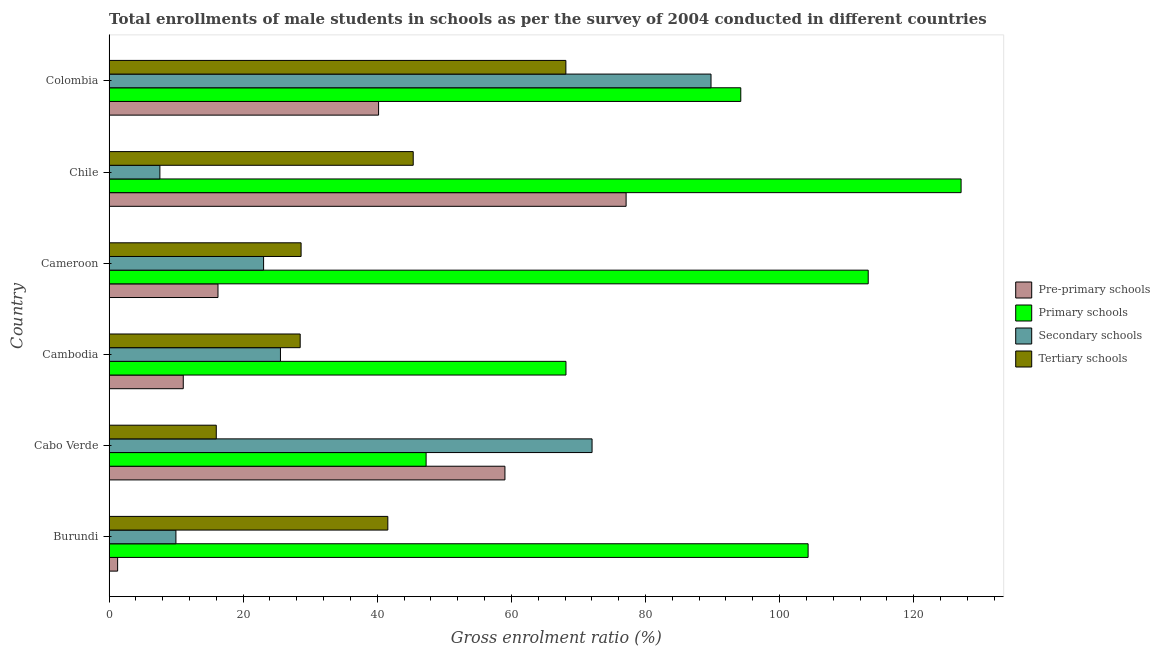What is the label of the 6th group of bars from the top?
Provide a succinct answer. Burundi. What is the gross enrolment ratio(male) in pre-primary schools in Chile?
Give a very brief answer. 77.11. Across all countries, what is the maximum gross enrolment ratio(male) in secondary schools?
Provide a succinct answer. 89.78. Across all countries, what is the minimum gross enrolment ratio(male) in primary schools?
Give a very brief answer. 47.28. In which country was the gross enrolment ratio(male) in tertiary schools maximum?
Give a very brief answer. Colombia. In which country was the gross enrolment ratio(male) in primary schools minimum?
Make the answer very short. Cabo Verde. What is the total gross enrolment ratio(male) in pre-primary schools in the graph?
Keep it short and to the point. 204.94. What is the difference between the gross enrolment ratio(male) in primary schools in Cambodia and that in Colombia?
Ensure brevity in your answer.  -26.07. What is the difference between the gross enrolment ratio(male) in pre-primary schools in Cameroon and the gross enrolment ratio(male) in secondary schools in Chile?
Provide a succinct answer. 8.66. What is the average gross enrolment ratio(male) in primary schools per country?
Your answer should be very brief. 92.37. What is the difference between the gross enrolment ratio(male) in pre-primary schools and gross enrolment ratio(male) in tertiary schools in Colombia?
Keep it short and to the point. -27.93. What is the ratio of the gross enrolment ratio(male) in secondary schools in Cameroon to that in Colombia?
Make the answer very short. 0.26. What is the difference between the highest and the second highest gross enrolment ratio(male) in pre-primary schools?
Offer a very short reply. 18.07. What is the difference between the highest and the lowest gross enrolment ratio(male) in secondary schools?
Your answer should be compact. 82.2. Is it the case that in every country, the sum of the gross enrolment ratio(male) in pre-primary schools and gross enrolment ratio(male) in primary schools is greater than the sum of gross enrolment ratio(male) in tertiary schools and gross enrolment ratio(male) in secondary schools?
Give a very brief answer. Yes. What does the 3rd bar from the top in Chile represents?
Your response must be concise. Primary schools. What does the 3rd bar from the bottom in Burundi represents?
Keep it short and to the point. Secondary schools. How many bars are there?
Your response must be concise. 24. What is the difference between two consecutive major ticks on the X-axis?
Your answer should be compact. 20. Does the graph contain any zero values?
Your response must be concise. No. Does the graph contain grids?
Offer a terse response. No. Where does the legend appear in the graph?
Your answer should be compact. Center right. How many legend labels are there?
Your answer should be very brief. 4. How are the legend labels stacked?
Make the answer very short. Vertical. What is the title of the graph?
Ensure brevity in your answer.  Total enrollments of male students in schools as per the survey of 2004 conducted in different countries. What is the label or title of the X-axis?
Your response must be concise. Gross enrolment ratio (%). What is the label or title of the Y-axis?
Your answer should be compact. Country. What is the Gross enrolment ratio (%) in Pre-primary schools in Burundi?
Offer a terse response. 1.28. What is the Gross enrolment ratio (%) in Primary schools in Burundi?
Provide a succinct answer. 104.26. What is the Gross enrolment ratio (%) in Secondary schools in Burundi?
Make the answer very short. 9.97. What is the Gross enrolment ratio (%) in Tertiary schools in Burundi?
Provide a succinct answer. 41.58. What is the Gross enrolment ratio (%) of Pre-primary schools in Cabo Verde?
Offer a terse response. 59.04. What is the Gross enrolment ratio (%) of Primary schools in Cabo Verde?
Your answer should be very brief. 47.28. What is the Gross enrolment ratio (%) of Secondary schools in Cabo Verde?
Ensure brevity in your answer.  72.04. What is the Gross enrolment ratio (%) of Tertiary schools in Cabo Verde?
Offer a very short reply. 15.99. What is the Gross enrolment ratio (%) in Pre-primary schools in Cambodia?
Your answer should be very brief. 11.07. What is the Gross enrolment ratio (%) of Primary schools in Cambodia?
Your response must be concise. 68.14. What is the Gross enrolment ratio (%) in Secondary schools in Cambodia?
Keep it short and to the point. 25.56. What is the Gross enrolment ratio (%) of Tertiary schools in Cambodia?
Offer a terse response. 28.51. What is the Gross enrolment ratio (%) of Pre-primary schools in Cameroon?
Your response must be concise. 16.24. What is the Gross enrolment ratio (%) in Primary schools in Cameroon?
Offer a very short reply. 113.22. What is the Gross enrolment ratio (%) in Secondary schools in Cameroon?
Make the answer very short. 23.05. What is the Gross enrolment ratio (%) in Tertiary schools in Cameroon?
Give a very brief answer. 28.64. What is the Gross enrolment ratio (%) in Pre-primary schools in Chile?
Offer a terse response. 77.11. What is the Gross enrolment ratio (%) of Primary schools in Chile?
Make the answer very short. 127.07. What is the Gross enrolment ratio (%) of Secondary schools in Chile?
Provide a succinct answer. 7.58. What is the Gross enrolment ratio (%) in Tertiary schools in Chile?
Give a very brief answer. 45.36. What is the Gross enrolment ratio (%) of Pre-primary schools in Colombia?
Your response must be concise. 40.2. What is the Gross enrolment ratio (%) of Primary schools in Colombia?
Your answer should be compact. 94.22. What is the Gross enrolment ratio (%) of Secondary schools in Colombia?
Provide a succinct answer. 89.78. What is the Gross enrolment ratio (%) of Tertiary schools in Colombia?
Your response must be concise. 68.13. Across all countries, what is the maximum Gross enrolment ratio (%) of Pre-primary schools?
Provide a succinct answer. 77.11. Across all countries, what is the maximum Gross enrolment ratio (%) of Primary schools?
Offer a very short reply. 127.07. Across all countries, what is the maximum Gross enrolment ratio (%) in Secondary schools?
Keep it short and to the point. 89.78. Across all countries, what is the maximum Gross enrolment ratio (%) of Tertiary schools?
Your answer should be very brief. 68.13. Across all countries, what is the minimum Gross enrolment ratio (%) of Pre-primary schools?
Your response must be concise. 1.28. Across all countries, what is the minimum Gross enrolment ratio (%) of Primary schools?
Provide a short and direct response. 47.28. Across all countries, what is the minimum Gross enrolment ratio (%) of Secondary schools?
Give a very brief answer. 7.58. Across all countries, what is the minimum Gross enrolment ratio (%) in Tertiary schools?
Give a very brief answer. 15.99. What is the total Gross enrolment ratio (%) of Pre-primary schools in the graph?
Your response must be concise. 204.94. What is the total Gross enrolment ratio (%) in Primary schools in the graph?
Ensure brevity in your answer.  554.2. What is the total Gross enrolment ratio (%) of Secondary schools in the graph?
Your response must be concise. 227.97. What is the total Gross enrolment ratio (%) of Tertiary schools in the graph?
Make the answer very short. 228.2. What is the difference between the Gross enrolment ratio (%) in Pre-primary schools in Burundi and that in Cabo Verde?
Offer a terse response. -57.76. What is the difference between the Gross enrolment ratio (%) of Primary schools in Burundi and that in Cabo Verde?
Your response must be concise. 56.97. What is the difference between the Gross enrolment ratio (%) in Secondary schools in Burundi and that in Cabo Verde?
Ensure brevity in your answer.  -62.07. What is the difference between the Gross enrolment ratio (%) in Tertiary schools in Burundi and that in Cabo Verde?
Provide a succinct answer. 25.59. What is the difference between the Gross enrolment ratio (%) in Pre-primary schools in Burundi and that in Cambodia?
Provide a short and direct response. -9.79. What is the difference between the Gross enrolment ratio (%) in Primary schools in Burundi and that in Cambodia?
Your answer should be compact. 36.11. What is the difference between the Gross enrolment ratio (%) in Secondary schools in Burundi and that in Cambodia?
Keep it short and to the point. -15.59. What is the difference between the Gross enrolment ratio (%) in Tertiary schools in Burundi and that in Cambodia?
Your answer should be compact. 13.07. What is the difference between the Gross enrolment ratio (%) of Pre-primary schools in Burundi and that in Cameroon?
Your response must be concise. -14.97. What is the difference between the Gross enrolment ratio (%) of Primary schools in Burundi and that in Cameroon?
Provide a short and direct response. -8.97. What is the difference between the Gross enrolment ratio (%) of Secondary schools in Burundi and that in Cameroon?
Ensure brevity in your answer.  -13.08. What is the difference between the Gross enrolment ratio (%) of Tertiary schools in Burundi and that in Cameroon?
Your response must be concise. 12.94. What is the difference between the Gross enrolment ratio (%) of Pre-primary schools in Burundi and that in Chile?
Offer a very short reply. -75.84. What is the difference between the Gross enrolment ratio (%) in Primary schools in Burundi and that in Chile?
Offer a terse response. -22.82. What is the difference between the Gross enrolment ratio (%) in Secondary schools in Burundi and that in Chile?
Your answer should be compact. 2.39. What is the difference between the Gross enrolment ratio (%) of Tertiary schools in Burundi and that in Chile?
Your answer should be compact. -3.79. What is the difference between the Gross enrolment ratio (%) of Pre-primary schools in Burundi and that in Colombia?
Offer a very short reply. -38.92. What is the difference between the Gross enrolment ratio (%) in Primary schools in Burundi and that in Colombia?
Provide a short and direct response. 10.04. What is the difference between the Gross enrolment ratio (%) in Secondary schools in Burundi and that in Colombia?
Provide a short and direct response. -79.81. What is the difference between the Gross enrolment ratio (%) in Tertiary schools in Burundi and that in Colombia?
Make the answer very short. -26.55. What is the difference between the Gross enrolment ratio (%) in Pre-primary schools in Cabo Verde and that in Cambodia?
Ensure brevity in your answer.  47.98. What is the difference between the Gross enrolment ratio (%) of Primary schools in Cabo Verde and that in Cambodia?
Your response must be concise. -20.86. What is the difference between the Gross enrolment ratio (%) in Secondary schools in Cabo Verde and that in Cambodia?
Your answer should be very brief. 46.48. What is the difference between the Gross enrolment ratio (%) in Tertiary schools in Cabo Verde and that in Cambodia?
Make the answer very short. -12.51. What is the difference between the Gross enrolment ratio (%) in Pre-primary schools in Cabo Verde and that in Cameroon?
Ensure brevity in your answer.  42.8. What is the difference between the Gross enrolment ratio (%) in Primary schools in Cabo Verde and that in Cameroon?
Ensure brevity in your answer.  -65.94. What is the difference between the Gross enrolment ratio (%) of Secondary schools in Cabo Verde and that in Cameroon?
Keep it short and to the point. 48.99. What is the difference between the Gross enrolment ratio (%) of Tertiary schools in Cabo Verde and that in Cameroon?
Ensure brevity in your answer.  -12.65. What is the difference between the Gross enrolment ratio (%) of Pre-primary schools in Cabo Verde and that in Chile?
Provide a short and direct response. -18.07. What is the difference between the Gross enrolment ratio (%) of Primary schools in Cabo Verde and that in Chile?
Your answer should be very brief. -79.79. What is the difference between the Gross enrolment ratio (%) in Secondary schools in Cabo Verde and that in Chile?
Provide a short and direct response. 64.46. What is the difference between the Gross enrolment ratio (%) in Tertiary schools in Cabo Verde and that in Chile?
Make the answer very short. -29.37. What is the difference between the Gross enrolment ratio (%) in Pre-primary schools in Cabo Verde and that in Colombia?
Give a very brief answer. 18.85. What is the difference between the Gross enrolment ratio (%) of Primary schools in Cabo Verde and that in Colombia?
Provide a short and direct response. -46.93. What is the difference between the Gross enrolment ratio (%) of Secondary schools in Cabo Verde and that in Colombia?
Your answer should be compact. -17.74. What is the difference between the Gross enrolment ratio (%) of Tertiary schools in Cabo Verde and that in Colombia?
Make the answer very short. -52.14. What is the difference between the Gross enrolment ratio (%) of Pre-primary schools in Cambodia and that in Cameroon?
Offer a terse response. -5.18. What is the difference between the Gross enrolment ratio (%) of Primary schools in Cambodia and that in Cameroon?
Provide a succinct answer. -45.08. What is the difference between the Gross enrolment ratio (%) of Secondary schools in Cambodia and that in Cameroon?
Provide a short and direct response. 2.51. What is the difference between the Gross enrolment ratio (%) of Tertiary schools in Cambodia and that in Cameroon?
Your answer should be very brief. -0.13. What is the difference between the Gross enrolment ratio (%) of Pre-primary schools in Cambodia and that in Chile?
Provide a short and direct response. -66.05. What is the difference between the Gross enrolment ratio (%) in Primary schools in Cambodia and that in Chile?
Offer a terse response. -58.93. What is the difference between the Gross enrolment ratio (%) of Secondary schools in Cambodia and that in Chile?
Make the answer very short. 17.98. What is the difference between the Gross enrolment ratio (%) of Tertiary schools in Cambodia and that in Chile?
Keep it short and to the point. -16.86. What is the difference between the Gross enrolment ratio (%) in Pre-primary schools in Cambodia and that in Colombia?
Provide a short and direct response. -29.13. What is the difference between the Gross enrolment ratio (%) of Primary schools in Cambodia and that in Colombia?
Ensure brevity in your answer.  -26.07. What is the difference between the Gross enrolment ratio (%) in Secondary schools in Cambodia and that in Colombia?
Your response must be concise. -64.22. What is the difference between the Gross enrolment ratio (%) in Tertiary schools in Cambodia and that in Colombia?
Provide a succinct answer. -39.62. What is the difference between the Gross enrolment ratio (%) in Pre-primary schools in Cameroon and that in Chile?
Make the answer very short. -60.87. What is the difference between the Gross enrolment ratio (%) of Primary schools in Cameroon and that in Chile?
Your answer should be very brief. -13.85. What is the difference between the Gross enrolment ratio (%) of Secondary schools in Cameroon and that in Chile?
Your answer should be very brief. 15.46. What is the difference between the Gross enrolment ratio (%) of Tertiary schools in Cameroon and that in Chile?
Keep it short and to the point. -16.72. What is the difference between the Gross enrolment ratio (%) of Pre-primary schools in Cameroon and that in Colombia?
Keep it short and to the point. -23.95. What is the difference between the Gross enrolment ratio (%) in Primary schools in Cameroon and that in Colombia?
Keep it short and to the point. 19.01. What is the difference between the Gross enrolment ratio (%) in Secondary schools in Cameroon and that in Colombia?
Make the answer very short. -66.73. What is the difference between the Gross enrolment ratio (%) of Tertiary schools in Cameroon and that in Colombia?
Provide a short and direct response. -39.49. What is the difference between the Gross enrolment ratio (%) in Pre-primary schools in Chile and that in Colombia?
Make the answer very short. 36.92. What is the difference between the Gross enrolment ratio (%) of Primary schools in Chile and that in Colombia?
Provide a succinct answer. 32.86. What is the difference between the Gross enrolment ratio (%) in Secondary schools in Chile and that in Colombia?
Provide a short and direct response. -82.2. What is the difference between the Gross enrolment ratio (%) in Tertiary schools in Chile and that in Colombia?
Make the answer very short. -22.77. What is the difference between the Gross enrolment ratio (%) in Pre-primary schools in Burundi and the Gross enrolment ratio (%) in Primary schools in Cabo Verde?
Give a very brief answer. -46.01. What is the difference between the Gross enrolment ratio (%) in Pre-primary schools in Burundi and the Gross enrolment ratio (%) in Secondary schools in Cabo Verde?
Make the answer very short. -70.76. What is the difference between the Gross enrolment ratio (%) in Pre-primary schools in Burundi and the Gross enrolment ratio (%) in Tertiary schools in Cabo Verde?
Make the answer very short. -14.71. What is the difference between the Gross enrolment ratio (%) in Primary schools in Burundi and the Gross enrolment ratio (%) in Secondary schools in Cabo Verde?
Your answer should be very brief. 32.22. What is the difference between the Gross enrolment ratio (%) in Primary schools in Burundi and the Gross enrolment ratio (%) in Tertiary schools in Cabo Verde?
Offer a terse response. 88.27. What is the difference between the Gross enrolment ratio (%) of Secondary schools in Burundi and the Gross enrolment ratio (%) of Tertiary schools in Cabo Verde?
Your answer should be very brief. -6.02. What is the difference between the Gross enrolment ratio (%) in Pre-primary schools in Burundi and the Gross enrolment ratio (%) in Primary schools in Cambodia?
Your answer should be very brief. -66.87. What is the difference between the Gross enrolment ratio (%) of Pre-primary schools in Burundi and the Gross enrolment ratio (%) of Secondary schools in Cambodia?
Offer a very short reply. -24.28. What is the difference between the Gross enrolment ratio (%) in Pre-primary schools in Burundi and the Gross enrolment ratio (%) in Tertiary schools in Cambodia?
Offer a terse response. -27.23. What is the difference between the Gross enrolment ratio (%) in Primary schools in Burundi and the Gross enrolment ratio (%) in Secondary schools in Cambodia?
Your response must be concise. 78.7. What is the difference between the Gross enrolment ratio (%) of Primary schools in Burundi and the Gross enrolment ratio (%) of Tertiary schools in Cambodia?
Your answer should be very brief. 75.75. What is the difference between the Gross enrolment ratio (%) of Secondary schools in Burundi and the Gross enrolment ratio (%) of Tertiary schools in Cambodia?
Give a very brief answer. -18.53. What is the difference between the Gross enrolment ratio (%) in Pre-primary schools in Burundi and the Gross enrolment ratio (%) in Primary schools in Cameroon?
Ensure brevity in your answer.  -111.95. What is the difference between the Gross enrolment ratio (%) of Pre-primary schools in Burundi and the Gross enrolment ratio (%) of Secondary schools in Cameroon?
Give a very brief answer. -21.77. What is the difference between the Gross enrolment ratio (%) of Pre-primary schools in Burundi and the Gross enrolment ratio (%) of Tertiary schools in Cameroon?
Give a very brief answer. -27.36. What is the difference between the Gross enrolment ratio (%) of Primary schools in Burundi and the Gross enrolment ratio (%) of Secondary schools in Cameroon?
Offer a very short reply. 81.21. What is the difference between the Gross enrolment ratio (%) in Primary schools in Burundi and the Gross enrolment ratio (%) in Tertiary schools in Cameroon?
Provide a succinct answer. 75.62. What is the difference between the Gross enrolment ratio (%) of Secondary schools in Burundi and the Gross enrolment ratio (%) of Tertiary schools in Cameroon?
Your answer should be compact. -18.67. What is the difference between the Gross enrolment ratio (%) of Pre-primary schools in Burundi and the Gross enrolment ratio (%) of Primary schools in Chile?
Give a very brief answer. -125.8. What is the difference between the Gross enrolment ratio (%) in Pre-primary schools in Burundi and the Gross enrolment ratio (%) in Secondary schools in Chile?
Your answer should be very brief. -6.3. What is the difference between the Gross enrolment ratio (%) of Pre-primary schools in Burundi and the Gross enrolment ratio (%) of Tertiary schools in Chile?
Provide a short and direct response. -44.09. What is the difference between the Gross enrolment ratio (%) of Primary schools in Burundi and the Gross enrolment ratio (%) of Secondary schools in Chile?
Give a very brief answer. 96.68. What is the difference between the Gross enrolment ratio (%) in Primary schools in Burundi and the Gross enrolment ratio (%) in Tertiary schools in Chile?
Your response must be concise. 58.89. What is the difference between the Gross enrolment ratio (%) in Secondary schools in Burundi and the Gross enrolment ratio (%) in Tertiary schools in Chile?
Offer a very short reply. -35.39. What is the difference between the Gross enrolment ratio (%) in Pre-primary schools in Burundi and the Gross enrolment ratio (%) in Primary schools in Colombia?
Give a very brief answer. -92.94. What is the difference between the Gross enrolment ratio (%) of Pre-primary schools in Burundi and the Gross enrolment ratio (%) of Secondary schools in Colombia?
Provide a short and direct response. -88.5. What is the difference between the Gross enrolment ratio (%) of Pre-primary schools in Burundi and the Gross enrolment ratio (%) of Tertiary schools in Colombia?
Provide a succinct answer. -66.85. What is the difference between the Gross enrolment ratio (%) of Primary schools in Burundi and the Gross enrolment ratio (%) of Secondary schools in Colombia?
Keep it short and to the point. 14.48. What is the difference between the Gross enrolment ratio (%) in Primary schools in Burundi and the Gross enrolment ratio (%) in Tertiary schools in Colombia?
Offer a very short reply. 36.13. What is the difference between the Gross enrolment ratio (%) in Secondary schools in Burundi and the Gross enrolment ratio (%) in Tertiary schools in Colombia?
Provide a succinct answer. -58.16. What is the difference between the Gross enrolment ratio (%) of Pre-primary schools in Cabo Verde and the Gross enrolment ratio (%) of Primary schools in Cambodia?
Offer a very short reply. -9.1. What is the difference between the Gross enrolment ratio (%) of Pre-primary schools in Cabo Verde and the Gross enrolment ratio (%) of Secondary schools in Cambodia?
Offer a very short reply. 33.48. What is the difference between the Gross enrolment ratio (%) in Pre-primary schools in Cabo Verde and the Gross enrolment ratio (%) in Tertiary schools in Cambodia?
Offer a terse response. 30.54. What is the difference between the Gross enrolment ratio (%) in Primary schools in Cabo Verde and the Gross enrolment ratio (%) in Secondary schools in Cambodia?
Provide a succinct answer. 21.72. What is the difference between the Gross enrolment ratio (%) in Primary schools in Cabo Verde and the Gross enrolment ratio (%) in Tertiary schools in Cambodia?
Provide a short and direct response. 18.78. What is the difference between the Gross enrolment ratio (%) in Secondary schools in Cabo Verde and the Gross enrolment ratio (%) in Tertiary schools in Cambodia?
Provide a succinct answer. 43.53. What is the difference between the Gross enrolment ratio (%) in Pre-primary schools in Cabo Verde and the Gross enrolment ratio (%) in Primary schools in Cameroon?
Offer a terse response. -54.18. What is the difference between the Gross enrolment ratio (%) of Pre-primary schools in Cabo Verde and the Gross enrolment ratio (%) of Secondary schools in Cameroon?
Ensure brevity in your answer.  36. What is the difference between the Gross enrolment ratio (%) of Pre-primary schools in Cabo Verde and the Gross enrolment ratio (%) of Tertiary schools in Cameroon?
Ensure brevity in your answer.  30.4. What is the difference between the Gross enrolment ratio (%) of Primary schools in Cabo Verde and the Gross enrolment ratio (%) of Secondary schools in Cameroon?
Offer a very short reply. 24.24. What is the difference between the Gross enrolment ratio (%) of Primary schools in Cabo Verde and the Gross enrolment ratio (%) of Tertiary schools in Cameroon?
Provide a succinct answer. 18.64. What is the difference between the Gross enrolment ratio (%) in Secondary schools in Cabo Verde and the Gross enrolment ratio (%) in Tertiary schools in Cameroon?
Offer a terse response. 43.4. What is the difference between the Gross enrolment ratio (%) in Pre-primary schools in Cabo Verde and the Gross enrolment ratio (%) in Primary schools in Chile?
Provide a succinct answer. -68.03. What is the difference between the Gross enrolment ratio (%) of Pre-primary schools in Cabo Verde and the Gross enrolment ratio (%) of Secondary schools in Chile?
Offer a terse response. 51.46. What is the difference between the Gross enrolment ratio (%) in Pre-primary schools in Cabo Verde and the Gross enrolment ratio (%) in Tertiary schools in Chile?
Your answer should be very brief. 13.68. What is the difference between the Gross enrolment ratio (%) of Primary schools in Cabo Verde and the Gross enrolment ratio (%) of Secondary schools in Chile?
Ensure brevity in your answer.  39.7. What is the difference between the Gross enrolment ratio (%) of Primary schools in Cabo Verde and the Gross enrolment ratio (%) of Tertiary schools in Chile?
Give a very brief answer. 1.92. What is the difference between the Gross enrolment ratio (%) of Secondary schools in Cabo Verde and the Gross enrolment ratio (%) of Tertiary schools in Chile?
Provide a short and direct response. 26.67. What is the difference between the Gross enrolment ratio (%) in Pre-primary schools in Cabo Verde and the Gross enrolment ratio (%) in Primary schools in Colombia?
Offer a terse response. -35.17. What is the difference between the Gross enrolment ratio (%) of Pre-primary schools in Cabo Verde and the Gross enrolment ratio (%) of Secondary schools in Colombia?
Your answer should be very brief. -30.74. What is the difference between the Gross enrolment ratio (%) of Pre-primary schools in Cabo Verde and the Gross enrolment ratio (%) of Tertiary schools in Colombia?
Offer a terse response. -9.09. What is the difference between the Gross enrolment ratio (%) in Primary schools in Cabo Verde and the Gross enrolment ratio (%) in Secondary schools in Colombia?
Keep it short and to the point. -42.49. What is the difference between the Gross enrolment ratio (%) in Primary schools in Cabo Verde and the Gross enrolment ratio (%) in Tertiary schools in Colombia?
Ensure brevity in your answer.  -20.84. What is the difference between the Gross enrolment ratio (%) in Secondary schools in Cabo Verde and the Gross enrolment ratio (%) in Tertiary schools in Colombia?
Give a very brief answer. 3.91. What is the difference between the Gross enrolment ratio (%) in Pre-primary schools in Cambodia and the Gross enrolment ratio (%) in Primary schools in Cameroon?
Offer a terse response. -102.16. What is the difference between the Gross enrolment ratio (%) in Pre-primary schools in Cambodia and the Gross enrolment ratio (%) in Secondary schools in Cameroon?
Keep it short and to the point. -11.98. What is the difference between the Gross enrolment ratio (%) of Pre-primary schools in Cambodia and the Gross enrolment ratio (%) of Tertiary schools in Cameroon?
Offer a very short reply. -17.57. What is the difference between the Gross enrolment ratio (%) in Primary schools in Cambodia and the Gross enrolment ratio (%) in Secondary schools in Cameroon?
Provide a succinct answer. 45.1. What is the difference between the Gross enrolment ratio (%) of Primary schools in Cambodia and the Gross enrolment ratio (%) of Tertiary schools in Cameroon?
Keep it short and to the point. 39.5. What is the difference between the Gross enrolment ratio (%) in Secondary schools in Cambodia and the Gross enrolment ratio (%) in Tertiary schools in Cameroon?
Give a very brief answer. -3.08. What is the difference between the Gross enrolment ratio (%) in Pre-primary schools in Cambodia and the Gross enrolment ratio (%) in Primary schools in Chile?
Provide a short and direct response. -116.01. What is the difference between the Gross enrolment ratio (%) in Pre-primary schools in Cambodia and the Gross enrolment ratio (%) in Secondary schools in Chile?
Your answer should be compact. 3.49. What is the difference between the Gross enrolment ratio (%) of Pre-primary schools in Cambodia and the Gross enrolment ratio (%) of Tertiary schools in Chile?
Provide a succinct answer. -34.3. What is the difference between the Gross enrolment ratio (%) in Primary schools in Cambodia and the Gross enrolment ratio (%) in Secondary schools in Chile?
Keep it short and to the point. 60.56. What is the difference between the Gross enrolment ratio (%) of Primary schools in Cambodia and the Gross enrolment ratio (%) of Tertiary schools in Chile?
Provide a short and direct response. 22.78. What is the difference between the Gross enrolment ratio (%) in Secondary schools in Cambodia and the Gross enrolment ratio (%) in Tertiary schools in Chile?
Your response must be concise. -19.8. What is the difference between the Gross enrolment ratio (%) in Pre-primary schools in Cambodia and the Gross enrolment ratio (%) in Primary schools in Colombia?
Give a very brief answer. -83.15. What is the difference between the Gross enrolment ratio (%) of Pre-primary schools in Cambodia and the Gross enrolment ratio (%) of Secondary schools in Colombia?
Your response must be concise. -78.71. What is the difference between the Gross enrolment ratio (%) in Pre-primary schools in Cambodia and the Gross enrolment ratio (%) in Tertiary schools in Colombia?
Keep it short and to the point. -57.06. What is the difference between the Gross enrolment ratio (%) of Primary schools in Cambodia and the Gross enrolment ratio (%) of Secondary schools in Colombia?
Your answer should be compact. -21.63. What is the difference between the Gross enrolment ratio (%) in Primary schools in Cambodia and the Gross enrolment ratio (%) in Tertiary schools in Colombia?
Ensure brevity in your answer.  0.01. What is the difference between the Gross enrolment ratio (%) of Secondary schools in Cambodia and the Gross enrolment ratio (%) of Tertiary schools in Colombia?
Give a very brief answer. -42.57. What is the difference between the Gross enrolment ratio (%) of Pre-primary schools in Cameroon and the Gross enrolment ratio (%) of Primary schools in Chile?
Ensure brevity in your answer.  -110.83. What is the difference between the Gross enrolment ratio (%) of Pre-primary schools in Cameroon and the Gross enrolment ratio (%) of Secondary schools in Chile?
Offer a terse response. 8.66. What is the difference between the Gross enrolment ratio (%) in Pre-primary schools in Cameroon and the Gross enrolment ratio (%) in Tertiary schools in Chile?
Give a very brief answer. -29.12. What is the difference between the Gross enrolment ratio (%) of Primary schools in Cameroon and the Gross enrolment ratio (%) of Secondary schools in Chile?
Ensure brevity in your answer.  105.64. What is the difference between the Gross enrolment ratio (%) in Primary schools in Cameroon and the Gross enrolment ratio (%) in Tertiary schools in Chile?
Ensure brevity in your answer.  67.86. What is the difference between the Gross enrolment ratio (%) in Secondary schools in Cameroon and the Gross enrolment ratio (%) in Tertiary schools in Chile?
Provide a short and direct response. -22.32. What is the difference between the Gross enrolment ratio (%) of Pre-primary schools in Cameroon and the Gross enrolment ratio (%) of Primary schools in Colombia?
Offer a terse response. -77.97. What is the difference between the Gross enrolment ratio (%) in Pre-primary schools in Cameroon and the Gross enrolment ratio (%) in Secondary schools in Colombia?
Your answer should be compact. -73.53. What is the difference between the Gross enrolment ratio (%) in Pre-primary schools in Cameroon and the Gross enrolment ratio (%) in Tertiary schools in Colombia?
Give a very brief answer. -51.89. What is the difference between the Gross enrolment ratio (%) of Primary schools in Cameroon and the Gross enrolment ratio (%) of Secondary schools in Colombia?
Offer a very short reply. 23.45. What is the difference between the Gross enrolment ratio (%) in Primary schools in Cameroon and the Gross enrolment ratio (%) in Tertiary schools in Colombia?
Your answer should be compact. 45.09. What is the difference between the Gross enrolment ratio (%) in Secondary schools in Cameroon and the Gross enrolment ratio (%) in Tertiary schools in Colombia?
Provide a succinct answer. -45.08. What is the difference between the Gross enrolment ratio (%) in Pre-primary schools in Chile and the Gross enrolment ratio (%) in Primary schools in Colombia?
Offer a terse response. -17.1. What is the difference between the Gross enrolment ratio (%) of Pre-primary schools in Chile and the Gross enrolment ratio (%) of Secondary schools in Colombia?
Provide a succinct answer. -12.66. What is the difference between the Gross enrolment ratio (%) in Pre-primary schools in Chile and the Gross enrolment ratio (%) in Tertiary schools in Colombia?
Keep it short and to the point. 8.99. What is the difference between the Gross enrolment ratio (%) in Primary schools in Chile and the Gross enrolment ratio (%) in Secondary schools in Colombia?
Offer a very short reply. 37.3. What is the difference between the Gross enrolment ratio (%) of Primary schools in Chile and the Gross enrolment ratio (%) of Tertiary schools in Colombia?
Ensure brevity in your answer.  58.95. What is the difference between the Gross enrolment ratio (%) of Secondary schools in Chile and the Gross enrolment ratio (%) of Tertiary schools in Colombia?
Give a very brief answer. -60.55. What is the average Gross enrolment ratio (%) in Pre-primary schools per country?
Give a very brief answer. 34.16. What is the average Gross enrolment ratio (%) in Primary schools per country?
Keep it short and to the point. 92.37. What is the average Gross enrolment ratio (%) in Secondary schools per country?
Offer a terse response. 38. What is the average Gross enrolment ratio (%) in Tertiary schools per country?
Give a very brief answer. 38.03. What is the difference between the Gross enrolment ratio (%) of Pre-primary schools and Gross enrolment ratio (%) of Primary schools in Burundi?
Your answer should be very brief. -102.98. What is the difference between the Gross enrolment ratio (%) in Pre-primary schools and Gross enrolment ratio (%) in Secondary schools in Burundi?
Ensure brevity in your answer.  -8.69. What is the difference between the Gross enrolment ratio (%) of Pre-primary schools and Gross enrolment ratio (%) of Tertiary schools in Burundi?
Give a very brief answer. -40.3. What is the difference between the Gross enrolment ratio (%) in Primary schools and Gross enrolment ratio (%) in Secondary schools in Burundi?
Your response must be concise. 94.29. What is the difference between the Gross enrolment ratio (%) in Primary schools and Gross enrolment ratio (%) in Tertiary schools in Burundi?
Offer a terse response. 62.68. What is the difference between the Gross enrolment ratio (%) in Secondary schools and Gross enrolment ratio (%) in Tertiary schools in Burundi?
Offer a very short reply. -31.61. What is the difference between the Gross enrolment ratio (%) in Pre-primary schools and Gross enrolment ratio (%) in Primary schools in Cabo Verde?
Provide a succinct answer. 11.76. What is the difference between the Gross enrolment ratio (%) in Pre-primary schools and Gross enrolment ratio (%) in Secondary schools in Cabo Verde?
Offer a terse response. -13. What is the difference between the Gross enrolment ratio (%) in Pre-primary schools and Gross enrolment ratio (%) in Tertiary schools in Cabo Verde?
Offer a very short reply. 43.05. What is the difference between the Gross enrolment ratio (%) in Primary schools and Gross enrolment ratio (%) in Secondary schools in Cabo Verde?
Provide a short and direct response. -24.75. What is the difference between the Gross enrolment ratio (%) of Primary schools and Gross enrolment ratio (%) of Tertiary schools in Cabo Verde?
Offer a very short reply. 31.29. What is the difference between the Gross enrolment ratio (%) of Secondary schools and Gross enrolment ratio (%) of Tertiary schools in Cabo Verde?
Ensure brevity in your answer.  56.05. What is the difference between the Gross enrolment ratio (%) in Pre-primary schools and Gross enrolment ratio (%) in Primary schools in Cambodia?
Offer a terse response. -57.08. What is the difference between the Gross enrolment ratio (%) of Pre-primary schools and Gross enrolment ratio (%) of Secondary schools in Cambodia?
Your answer should be compact. -14.49. What is the difference between the Gross enrolment ratio (%) in Pre-primary schools and Gross enrolment ratio (%) in Tertiary schools in Cambodia?
Ensure brevity in your answer.  -17.44. What is the difference between the Gross enrolment ratio (%) of Primary schools and Gross enrolment ratio (%) of Secondary schools in Cambodia?
Offer a terse response. 42.58. What is the difference between the Gross enrolment ratio (%) of Primary schools and Gross enrolment ratio (%) of Tertiary schools in Cambodia?
Keep it short and to the point. 39.64. What is the difference between the Gross enrolment ratio (%) of Secondary schools and Gross enrolment ratio (%) of Tertiary schools in Cambodia?
Offer a terse response. -2.94. What is the difference between the Gross enrolment ratio (%) of Pre-primary schools and Gross enrolment ratio (%) of Primary schools in Cameroon?
Ensure brevity in your answer.  -96.98. What is the difference between the Gross enrolment ratio (%) in Pre-primary schools and Gross enrolment ratio (%) in Secondary schools in Cameroon?
Offer a terse response. -6.8. What is the difference between the Gross enrolment ratio (%) of Pre-primary schools and Gross enrolment ratio (%) of Tertiary schools in Cameroon?
Offer a terse response. -12.4. What is the difference between the Gross enrolment ratio (%) in Primary schools and Gross enrolment ratio (%) in Secondary schools in Cameroon?
Keep it short and to the point. 90.18. What is the difference between the Gross enrolment ratio (%) in Primary schools and Gross enrolment ratio (%) in Tertiary schools in Cameroon?
Offer a terse response. 84.58. What is the difference between the Gross enrolment ratio (%) in Secondary schools and Gross enrolment ratio (%) in Tertiary schools in Cameroon?
Make the answer very short. -5.59. What is the difference between the Gross enrolment ratio (%) of Pre-primary schools and Gross enrolment ratio (%) of Primary schools in Chile?
Provide a short and direct response. -49.96. What is the difference between the Gross enrolment ratio (%) in Pre-primary schools and Gross enrolment ratio (%) in Secondary schools in Chile?
Provide a succinct answer. 69.53. What is the difference between the Gross enrolment ratio (%) in Pre-primary schools and Gross enrolment ratio (%) in Tertiary schools in Chile?
Give a very brief answer. 31.75. What is the difference between the Gross enrolment ratio (%) in Primary schools and Gross enrolment ratio (%) in Secondary schools in Chile?
Your response must be concise. 119.49. What is the difference between the Gross enrolment ratio (%) of Primary schools and Gross enrolment ratio (%) of Tertiary schools in Chile?
Make the answer very short. 81.71. What is the difference between the Gross enrolment ratio (%) of Secondary schools and Gross enrolment ratio (%) of Tertiary schools in Chile?
Ensure brevity in your answer.  -37.78. What is the difference between the Gross enrolment ratio (%) in Pre-primary schools and Gross enrolment ratio (%) in Primary schools in Colombia?
Provide a succinct answer. -54.02. What is the difference between the Gross enrolment ratio (%) of Pre-primary schools and Gross enrolment ratio (%) of Secondary schools in Colombia?
Ensure brevity in your answer.  -49.58. What is the difference between the Gross enrolment ratio (%) in Pre-primary schools and Gross enrolment ratio (%) in Tertiary schools in Colombia?
Your answer should be very brief. -27.93. What is the difference between the Gross enrolment ratio (%) in Primary schools and Gross enrolment ratio (%) in Secondary schools in Colombia?
Make the answer very short. 4.44. What is the difference between the Gross enrolment ratio (%) in Primary schools and Gross enrolment ratio (%) in Tertiary schools in Colombia?
Your answer should be compact. 26.09. What is the difference between the Gross enrolment ratio (%) in Secondary schools and Gross enrolment ratio (%) in Tertiary schools in Colombia?
Your response must be concise. 21.65. What is the ratio of the Gross enrolment ratio (%) of Pre-primary schools in Burundi to that in Cabo Verde?
Provide a short and direct response. 0.02. What is the ratio of the Gross enrolment ratio (%) of Primary schools in Burundi to that in Cabo Verde?
Give a very brief answer. 2.2. What is the ratio of the Gross enrolment ratio (%) in Secondary schools in Burundi to that in Cabo Verde?
Keep it short and to the point. 0.14. What is the ratio of the Gross enrolment ratio (%) in Tertiary schools in Burundi to that in Cabo Verde?
Offer a terse response. 2.6. What is the ratio of the Gross enrolment ratio (%) of Pre-primary schools in Burundi to that in Cambodia?
Offer a very short reply. 0.12. What is the ratio of the Gross enrolment ratio (%) of Primary schools in Burundi to that in Cambodia?
Offer a terse response. 1.53. What is the ratio of the Gross enrolment ratio (%) in Secondary schools in Burundi to that in Cambodia?
Give a very brief answer. 0.39. What is the ratio of the Gross enrolment ratio (%) in Tertiary schools in Burundi to that in Cambodia?
Your response must be concise. 1.46. What is the ratio of the Gross enrolment ratio (%) of Pre-primary schools in Burundi to that in Cameroon?
Ensure brevity in your answer.  0.08. What is the ratio of the Gross enrolment ratio (%) of Primary schools in Burundi to that in Cameroon?
Your answer should be very brief. 0.92. What is the ratio of the Gross enrolment ratio (%) of Secondary schools in Burundi to that in Cameroon?
Keep it short and to the point. 0.43. What is the ratio of the Gross enrolment ratio (%) in Tertiary schools in Burundi to that in Cameroon?
Your answer should be compact. 1.45. What is the ratio of the Gross enrolment ratio (%) in Pre-primary schools in Burundi to that in Chile?
Keep it short and to the point. 0.02. What is the ratio of the Gross enrolment ratio (%) in Primary schools in Burundi to that in Chile?
Provide a short and direct response. 0.82. What is the ratio of the Gross enrolment ratio (%) in Secondary schools in Burundi to that in Chile?
Offer a terse response. 1.32. What is the ratio of the Gross enrolment ratio (%) in Tertiary schools in Burundi to that in Chile?
Your answer should be compact. 0.92. What is the ratio of the Gross enrolment ratio (%) of Pre-primary schools in Burundi to that in Colombia?
Your response must be concise. 0.03. What is the ratio of the Gross enrolment ratio (%) in Primary schools in Burundi to that in Colombia?
Your response must be concise. 1.11. What is the ratio of the Gross enrolment ratio (%) in Tertiary schools in Burundi to that in Colombia?
Make the answer very short. 0.61. What is the ratio of the Gross enrolment ratio (%) in Pre-primary schools in Cabo Verde to that in Cambodia?
Keep it short and to the point. 5.34. What is the ratio of the Gross enrolment ratio (%) of Primary schools in Cabo Verde to that in Cambodia?
Your answer should be compact. 0.69. What is the ratio of the Gross enrolment ratio (%) in Secondary schools in Cabo Verde to that in Cambodia?
Give a very brief answer. 2.82. What is the ratio of the Gross enrolment ratio (%) of Tertiary schools in Cabo Verde to that in Cambodia?
Your answer should be compact. 0.56. What is the ratio of the Gross enrolment ratio (%) of Pre-primary schools in Cabo Verde to that in Cameroon?
Give a very brief answer. 3.63. What is the ratio of the Gross enrolment ratio (%) of Primary schools in Cabo Verde to that in Cameroon?
Offer a terse response. 0.42. What is the ratio of the Gross enrolment ratio (%) of Secondary schools in Cabo Verde to that in Cameroon?
Give a very brief answer. 3.13. What is the ratio of the Gross enrolment ratio (%) in Tertiary schools in Cabo Verde to that in Cameroon?
Keep it short and to the point. 0.56. What is the ratio of the Gross enrolment ratio (%) of Pre-primary schools in Cabo Verde to that in Chile?
Offer a very short reply. 0.77. What is the ratio of the Gross enrolment ratio (%) of Primary schools in Cabo Verde to that in Chile?
Give a very brief answer. 0.37. What is the ratio of the Gross enrolment ratio (%) in Secondary schools in Cabo Verde to that in Chile?
Provide a short and direct response. 9.5. What is the ratio of the Gross enrolment ratio (%) in Tertiary schools in Cabo Verde to that in Chile?
Make the answer very short. 0.35. What is the ratio of the Gross enrolment ratio (%) in Pre-primary schools in Cabo Verde to that in Colombia?
Give a very brief answer. 1.47. What is the ratio of the Gross enrolment ratio (%) of Primary schools in Cabo Verde to that in Colombia?
Offer a terse response. 0.5. What is the ratio of the Gross enrolment ratio (%) of Secondary schools in Cabo Verde to that in Colombia?
Provide a short and direct response. 0.8. What is the ratio of the Gross enrolment ratio (%) of Tertiary schools in Cabo Verde to that in Colombia?
Your answer should be very brief. 0.23. What is the ratio of the Gross enrolment ratio (%) in Pre-primary schools in Cambodia to that in Cameroon?
Offer a very short reply. 0.68. What is the ratio of the Gross enrolment ratio (%) of Primary schools in Cambodia to that in Cameroon?
Provide a succinct answer. 0.6. What is the ratio of the Gross enrolment ratio (%) in Secondary schools in Cambodia to that in Cameroon?
Provide a short and direct response. 1.11. What is the ratio of the Gross enrolment ratio (%) in Tertiary schools in Cambodia to that in Cameroon?
Offer a very short reply. 1. What is the ratio of the Gross enrolment ratio (%) of Pre-primary schools in Cambodia to that in Chile?
Offer a very short reply. 0.14. What is the ratio of the Gross enrolment ratio (%) in Primary schools in Cambodia to that in Chile?
Your response must be concise. 0.54. What is the ratio of the Gross enrolment ratio (%) in Secondary schools in Cambodia to that in Chile?
Offer a terse response. 3.37. What is the ratio of the Gross enrolment ratio (%) of Tertiary schools in Cambodia to that in Chile?
Your answer should be very brief. 0.63. What is the ratio of the Gross enrolment ratio (%) in Pre-primary schools in Cambodia to that in Colombia?
Provide a succinct answer. 0.28. What is the ratio of the Gross enrolment ratio (%) of Primary schools in Cambodia to that in Colombia?
Provide a short and direct response. 0.72. What is the ratio of the Gross enrolment ratio (%) of Secondary schools in Cambodia to that in Colombia?
Give a very brief answer. 0.28. What is the ratio of the Gross enrolment ratio (%) of Tertiary schools in Cambodia to that in Colombia?
Keep it short and to the point. 0.42. What is the ratio of the Gross enrolment ratio (%) of Pre-primary schools in Cameroon to that in Chile?
Provide a short and direct response. 0.21. What is the ratio of the Gross enrolment ratio (%) in Primary schools in Cameroon to that in Chile?
Ensure brevity in your answer.  0.89. What is the ratio of the Gross enrolment ratio (%) of Secondary schools in Cameroon to that in Chile?
Make the answer very short. 3.04. What is the ratio of the Gross enrolment ratio (%) of Tertiary schools in Cameroon to that in Chile?
Keep it short and to the point. 0.63. What is the ratio of the Gross enrolment ratio (%) in Pre-primary schools in Cameroon to that in Colombia?
Your response must be concise. 0.4. What is the ratio of the Gross enrolment ratio (%) of Primary schools in Cameroon to that in Colombia?
Give a very brief answer. 1.2. What is the ratio of the Gross enrolment ratio (%) of Secondary schools in Cameroon to that in Colombia?
Give a very brief answer. 0.26. What is the ratio of the Gross enrolment ratio (%) of Tertiary schools in Cameroon to that in Colombia?
Your answer should be compact. 0.42. What is the ratio of the Gross enrolment ratio (%) in Pre-primary schools in Chile to that in Colombia?
Give a very brief answer. 1.92. What is the ratio of the Gross enrolment ratio (%) in Primary schools in Chile to that in Colombia?
Give a very brief answer. 1.35. What is the ratio of the Gross enrolment ratio (%) in Secondary schools in Chile to that in Colombia?
Provide a short and direct response. 0.08. What is the ratio of the Gross enrolment ratio (%) in Tertiary schools in Chile to that in Colombia?
Keep it short and to the point. 0.67. What is the difference between the highest and the second highest Gross enrolment ratio (%) of Pre-primary schools?
Give a very brief answer. 18.07. What is the difference between the highest and the second highest Gross enrolment ratio (%) of Primary schools?
Your response must be concise. 13.85. What is the difference between the highest and the second highest Gross enrolment ratio (%) of Secondary schools?
Offer a terse response. 17.74. What is the difference between the highest and the second highest Gross enrolment ratio (%) in Tertiary schools?
Your response must be concise. 22.77. What is the difference between the highest and the lowest Gross enrolment ratio (%) of Pre-primary schools?
Give a very brief answer. 75.84. What is the difference between the highest and the lowest Gross enrolment ratio (%) in Primary schools?
Your answer should be very brief. 79.79. What is the difference between the highest and the lowest Gross enrolment ratio (%) of Secondary schools?
Ensure brevity in your answer.  82.2. What is the difference between the highest and the lowest Gross enrolment ratio (%) of Tertiary schools?
Ensure brevity in your answer.  52.14. 